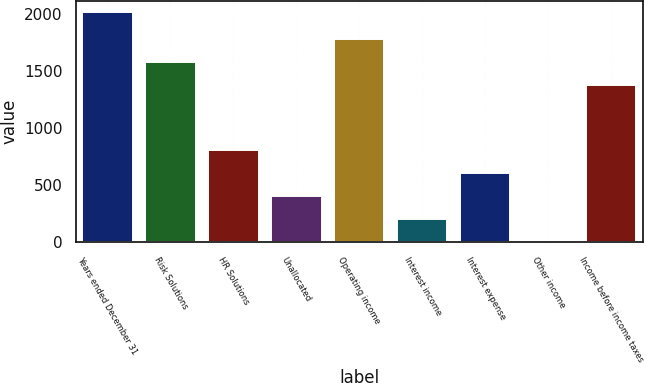Convert chart to OTSL. <chart><loc_0><loc_0><loc_500><loc_500><bar_chart><fcel>Years ended December 31<fcel>Risk Solutions<fcel>HR Solutions<fcel>Unallocated<fcel>Operating income<fcel>Interest income<fcel>Interest expense<fcel>Other income<fcel>Income before income taxes<nl><fcel>2012<fcel>1581<fcel>806<fcel>404<fcel>1782<fcel>203<fcel>605<fcel>2<fcel>1380<nl></chart> 